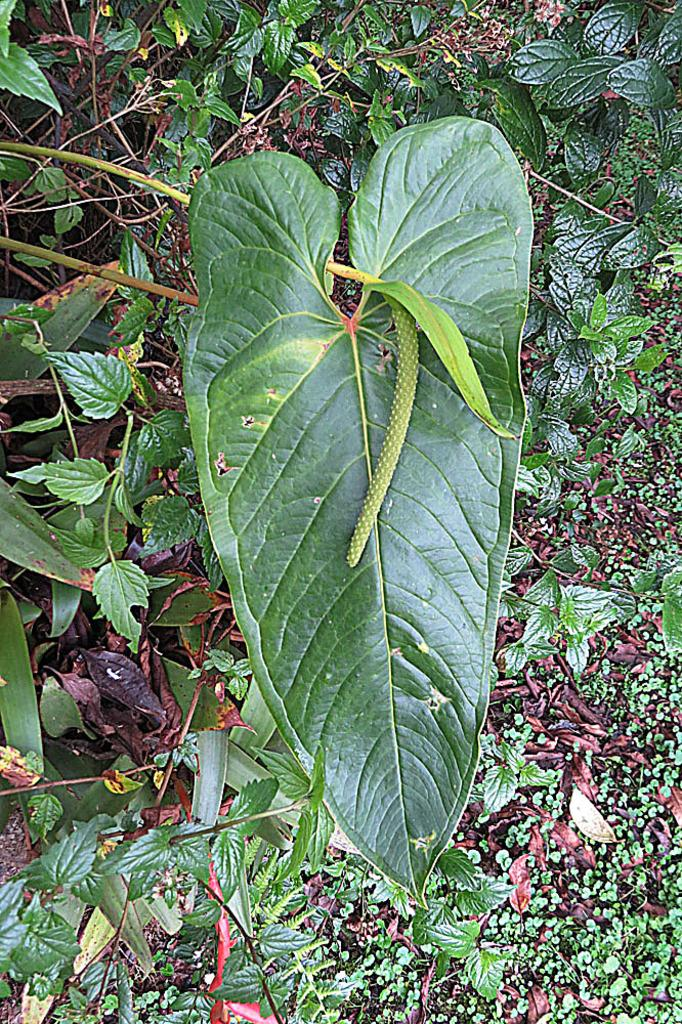What is present on a leaf in the image? There is a pest on a leaf in the image. What type of vegetation can be seen in the image? There are green leaves in the image. What type of tank is visible in the image? There is no tank present in the image; it features a pest on a leaf and green leaves. What is the outcome of the meeting in the image? There is no meeting present in the image, so it's not possible to determine the outcome. 